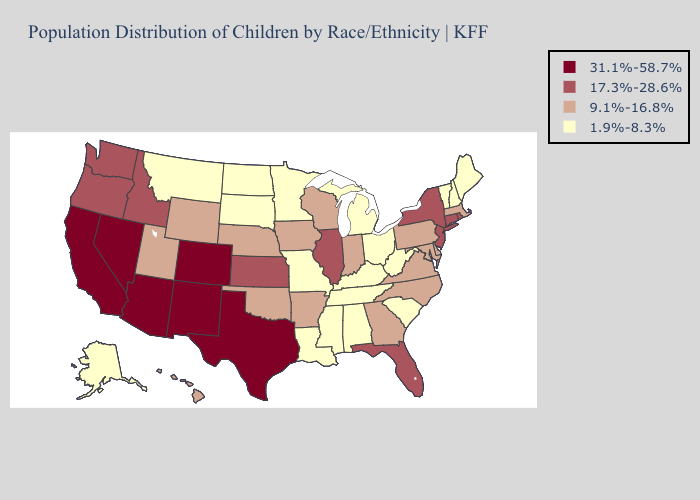Does Rhode Island have the lowest value in the USA?
Give a very brief answer. No. Name the states that have a value in the range 1.9%-8.3%?
Concise answer only. Alabama, Alaska, Kentucky, Louisiana, Maine, Michigan, Minnesota, Mississippi, Missouri, Montana, New Hampshire, North Dakota, Ohio, South Carolina, South Dakota, Tennessee, Vermont, West Virginia. Does Maryland have the same value as West Virginia?
Give a very brief answer. No. Among the states that border Wisconsin , does Minnesota have the lowest value?
Short answer required. Yes. What is the lowest value in the MidWest?
Be succinct. 1.9%-8.3%. Among the states that border Vermont , which have the lowest value?
Be succinct. New Hampshire. What is the highest value in states that border Tennessee?
Short answer required. 9.1%-16.8%. Does Idaho have a higher value than California?
Answer briefly. No. What is the value of Nebraska?
Give a very brief answer. 9.1%-16.8%. Name the states that have a value in the range 17.3%-28.6%?
Concise answer only. Connecticut, Florida, Idaho, Illinois, Kansas, New Jersey, New York, Oregon, Rhode Island, Washington. Does Montana have the lowest value in the USA?
Keep it brief. Yes. What is the value of Minnesota?
Short answer required. 1.9%-8.3%. Does Delaware have the lowest value in the South?
Give a very brief answer. No. Does North Carolina have a lower value than Wisconsin?
Answer briefly. No. Does Mississippi have the lowest value in the South?
Be succinct. Yes. 